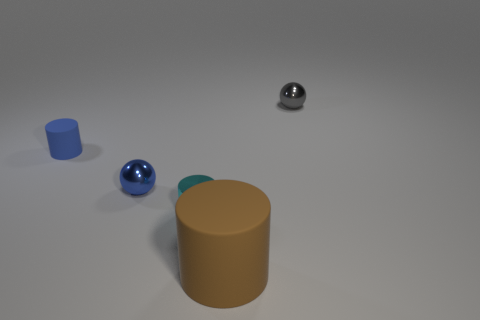Are the small ball that is in front of the gray ball and the cyan cylinder made of the same material?
Your response must be concise. Yes. What shape is the matte object that is behind the cyan metal cylinder?
Keep it short and to the point. Cylinder. What number of cyan objects have the same size as the brown rubber object?
Offer a very short reply. 0. What size is the gray ball?
Provide a short and direct response. Small. There is a tiny blue metal sphere; how many tiny gray objects are in front of it?
Your response must be concise. 0. What shape is the small object that is the same material as the brown cylinder?
Provide a short and direct response. Cylinder. Are there fewer small metallic cylinders that are on the left side of the blue shiny ball than tiny metallic things left of the small rubber thing?
Your answer should be compact. No. Are there more shiny cylinders than tiny blue things?
Offer a terse response. No. What is the tiny cyan cylinder made of?
Offer a terse response. Metal. What color is the tiny metal ball that is right of the small blue sphere?
Offer a terse response. Gray. 